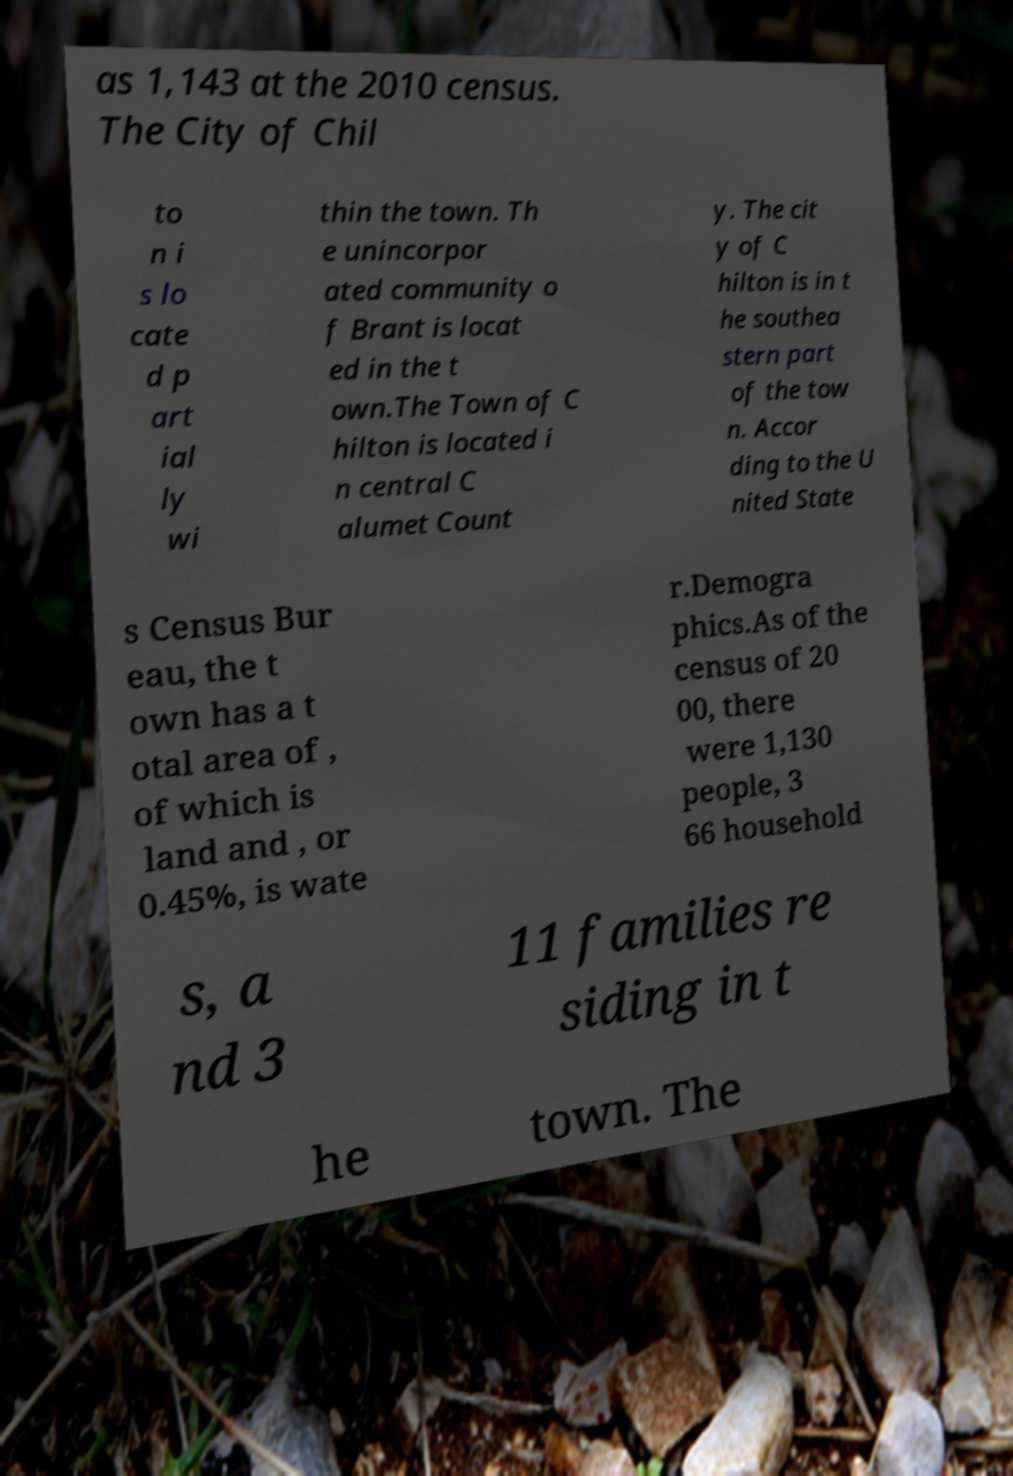I need the written content from this picture converted into text. Can you do that? as 1,143 at the 2010 census. The City of Chil to n i s lo cate d p art ial ly wi thin the town. Th e unincorpor ated community o f Brant is locat ed in the t own.The Town of C hilton is located i n central C alumet Count y. The cit y of C hilton is in t he southea stern part of the tow n. Accor ding to the U nited State s Census Bur eau, the t own has a t otal area of , of which is land and , or 0.45%, is wate r.Demogra phics.As of the census of 20 00, there were 1,130 people, 3 66 household s, a nd 3 11 families re siding in t he town. The 